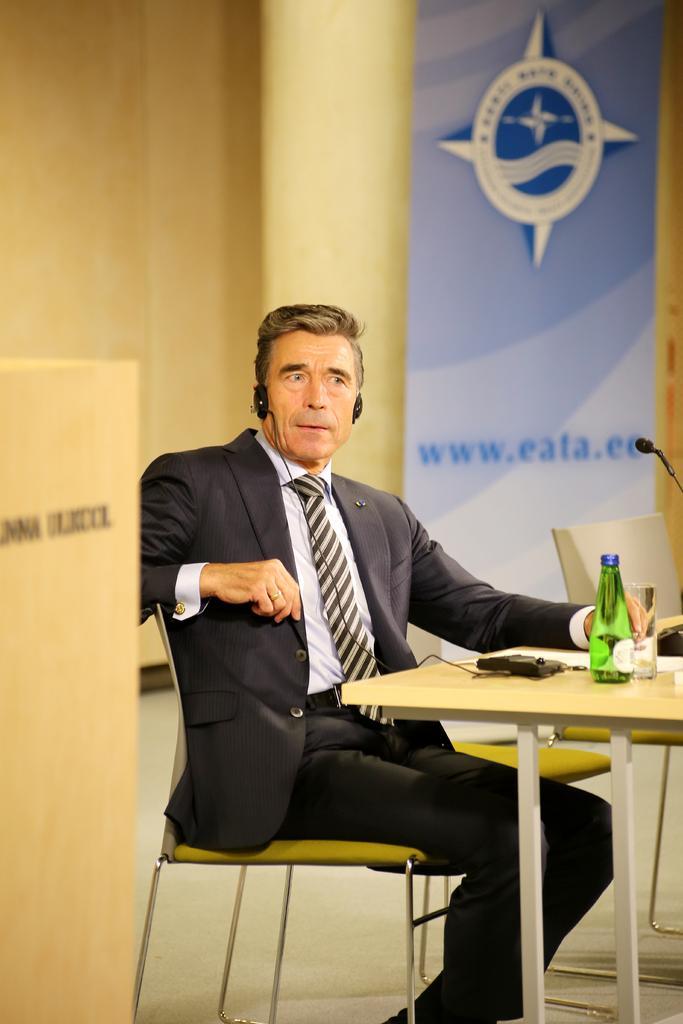Could you give a brief overview of what you see in this image? a person is sitting on a chair. in front of him there is a table on which there is a bottle and a glass. behind him there is a banner on which www. eata. co is written. 